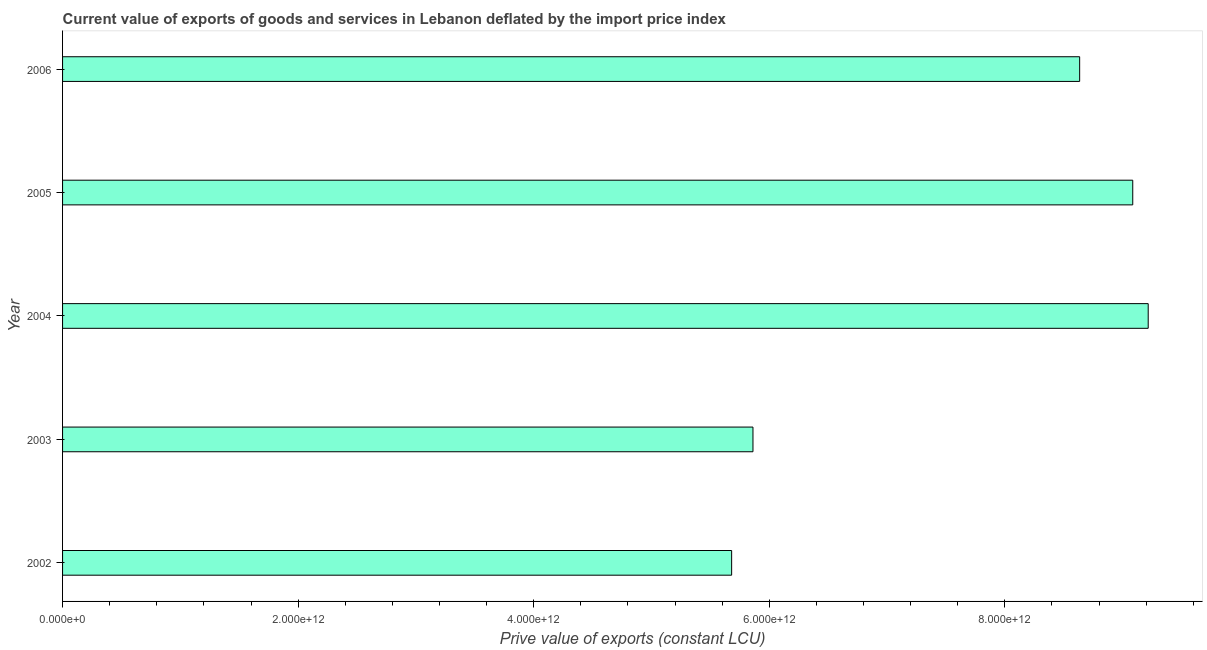Does the graph contain grids?
Keep it short and to the point. No. What is the title of the graph?
Your response must be concise. Current value of exports of goods and services in Lebanon deflated by the import price index. What is the label or title of the X-axis?
Ensure brevity in your answer.  Prive value of exports (constant LCU). What is the price value of exports in 2002?
Ensure brevity in your answer.  5.68e+12. Across all years, what is the maximum price value of exports?
Offer a terse response. 9.22e+12. Across all years, what is the minimum price value of exports?
Give a very brief answer. 5.68e+12. What is the sum of the price value of exports?
Offer a very short reply. 3.85e+13. What is the difference between the price value of exports in 2003 and 2006?
Your answer should be very brief. -2.77e+12. What is the average price value of exports per year?
Offer a terse response. 7.70e+12. What is the median price value of exports?
Keep it short and to the point. 8.64e+12. What is the ratio of the price value of exports in 2003 to that in 2004?
Your answer should be compact. 0.64. Is the difference between the price value of exports in 2004 and 2005 greater than the difference between any two years?
Your answer should be compact. No. What is the difference between the highest and the second highest price value of exports?
Keep it short and to the point. 1.31e+11. Is the sum of the price value of exports in 2004 and 2005 greater than the maximum price value of exports across all years?
Offer a very short reply. Yes. What is the difference between the highest and the lowest price value of exports?
Give a very brief answer. 3.54e+12. In how many years, is the price value of exports greater than the average price value of exports taken over all years?
Give a very brief answer. 3. What is the difference between two consecutive major ticks on the X-axis?
Offer a very short reply. 2.00e+12. What is the Prive value of exports (constant LCU) of 2002?
Keep it short and to the point. 5.68e+12. What is the Prive value of exports (constant LCU) of 2003?
Offer a terse response. 5.86e+12. What is the Prive value of exports (constant LCU) of 2004?
Your answer should be compact. 9.22e+12. What is the Prive value of exports (constant LCU) of 2005?
Your response must be concise. 9.09e+12. What is the Prive value of exports (constant LCU) of 2006?
Provide a succinct answer. 8.64e+12. What is the difference between the Prive value of exports (constant LCU) in 2002 and 2003?
Keep it short and to the point. -1.81e+11. What is the difference between the Prive value of exports (constant LCU) in 2002 and 2004?
Give a very brief answer. -3.54e+12. What is the difference between the Prive value of exports (constant LCU) in 2002 and 2005?
Keep it short and to the point. -3.41e+12. What is the difference between the Prive value of exports (constant LCU) in 2002 and 2006?
Offer a terse response. -2.95e+12. What is the difference between the Prive value of exports (constant LCU) in 2003 and 2004?
Your answer should be very brief. -3.36e+12. What is the difference between the Prive value of exports (constant LCU) in 2003 and 2005?
Provide a short and direct response. -3.22e+12. What is the difference between the Prive value of exports (constant LCU) in 2003 and 2006?
Ensure brevity in your answer.  -2.77e+12. What is the difference between the Prive value of exports (constant LCU) in 2004 and 2005?
Offer a very short reply. 1.31e+11. What is the difference between the Prive value of exports (constant LCU) in 2004 and 2006?
Offer a very short reply. 5.82e+11. What is the difference between the Prive value of exports (constant LCU) in 2005 and 2006?
Ensure brevity in your answer.  4.51e+11. What is the ratio of the Prive value of exports (constant LCU) in 2002 to that in 2003?
Offer a terse response. 0.97. What is the ratio of the Prive value of exports (constant LCU) in 2002 to that in 2004?
Give a very brief answer. 0.62. What is the ratio of the Prive value of exports (constant LCU) in 2002 to that in 2006?
Your answer should be very brief. 0.66. What is the ratio of the Prive value of exports (constant LCU) in 2003 to that in 2004?
Offer a very short reply. 0.64. What is the ratio of the Prive value of exports (constant LCU) in 2003 to that in 2005?
Make the answer very short. 0.65. What is the ratio of the Prive value of exports (constant LCU) in 2003 to that in 2006?
Provide a succinct answer. 0.68. What is the ratio of the Prive value of exports (constant LCU) in 2004 to that in 2005?
Make the answer very short. 1.01. What is the ratio of the Prive value of exports (constant LCU) in 2004 to that in 2006?
Give a very brief answer. 1.07. What is the ratio of the Prive value of exports (constant LCU) in 2005 to that in 2006?
Make the answer very short. 1.05. 